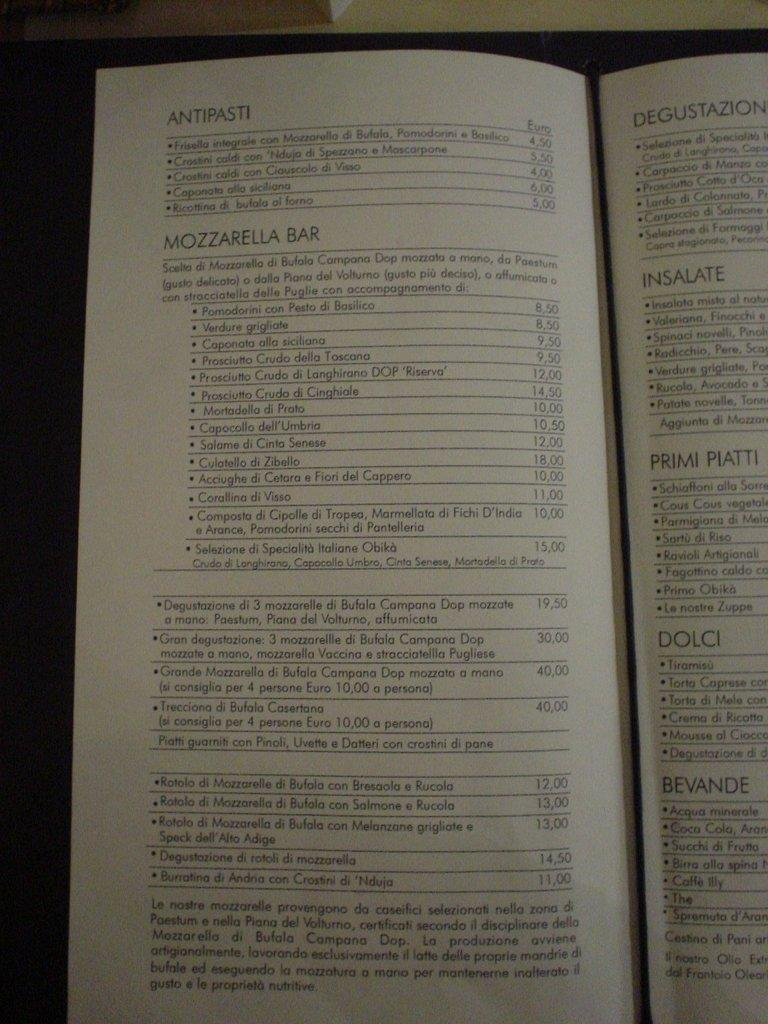<image>
Give a short and clear explanation of the subsequent image. A menu is open to show selections of Antipasta and Mozzarella Bar and prices. 